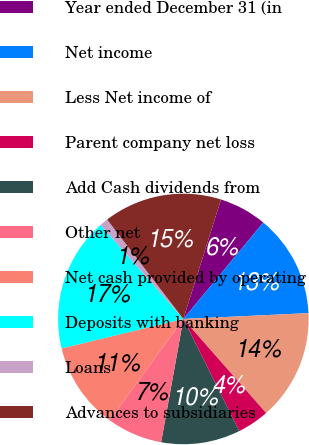Convert chart. <chart><loc_0><loc_0><loc_500><loc_500><pie_chart><fcel>Year ended December 31 (in<fcel>Net income<fcel>Less Net income of<fcel>Parent company net loss<fcel>Add Cash dividends from<fcel>Other net<fcel>Net cash provided by operating<fcel>Deposits with banking<fcel>Loans<fcel>Advances to subsidiaries<nl><fcel>6.15%<fcel>13.25%<fcel>14.26%<fcel>4.12%<fcel>10.2%<fcel>7.16%<fcel>11.22%<fcel>17.3%<fcel>1.07%<fcel>15.27%<nl></chart> 